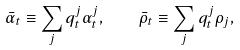Convert formula to latex. <formula><loc_0><loc_0><loc_500><loc_500>\bar { \alpha } _ { t } \equiv \sum _ { j } q ^ { j } _ { t } \alpha ^ { j } _ { t } , \quad \bar { \rho } _ { t } \equiv \sum _ { j } q ^ { j } _ { t } \rho _ { j } ,</formula> 